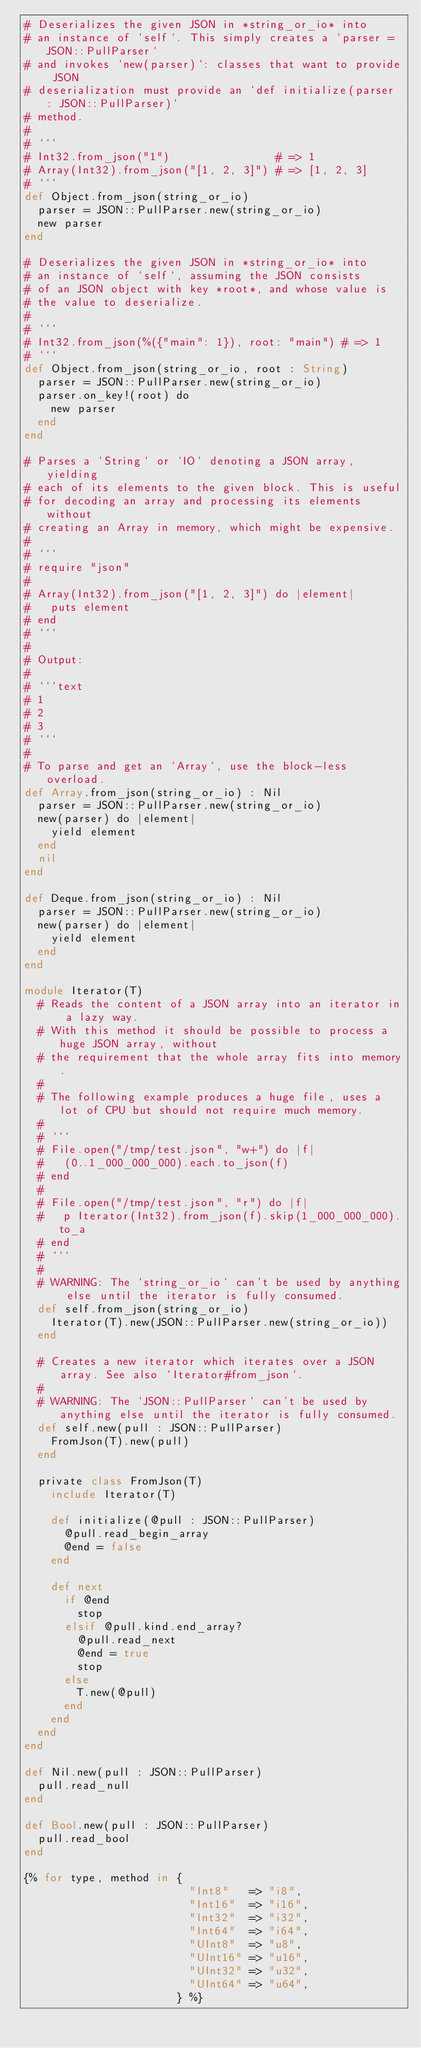<code> <loc_0><loc_0><loc_500><loc_500><_Crystal_># Deserializes the given JSON in *string_or_io* into
# an instance of `self`. This simply creates a `parser = JSON::PullParser`
# and invokes `new(parser)`: classes that want to provide JSON
# deserialization must provide an `def initialize(parser : JSON::PullParser)`
# method.
#
# ```
# Int32.from_json("1")                # => 1
# Array(Int32).from_json("[1, 2, 3]") # => [1, 2, 3]
# ```
def Object.from_json(string_or_io)
  parser = JSON::PullParser.new(string_or_io)
  new parser
end

# Deserializes the given JSON in *string_or_io* into
# an instance of `self`, assuming the JSON consists
# of an JSON object with key *root*, and whose value is
# the value to deserialize.
#
# ```
# Int32.from_json(%({"main": 1}), root: "main") # => 1
# ```
def Object.from_json(string_or_io, root : String)
  parser = JSON::PullParser.new(string_or_io)
  parser.on_key!(root) do
    new parser
  end
end

# Parses a `String` or `IO` denoting a JSON array, yielding
# each of its elements to the given block. This is useful
# for decoding an array and processing its elements without
# creating an Array in memory, which might be expensive.
#
# ```
# require "json"
#
# Array(Int32).from_json("[1, 2, 3]") do |element|
#   puts element
# end
# ```
#
# Output:
#
# ```text
# 1
# 2
# 3
# ```
#
# To parse and get an `Array`, use the block-less overload.
def Array.from_json(string_or_io) : Nil
  parser = JSON::PullParser.new(string_or_io)
  new(parser) do |element|
    yield element
  end
  nil
end

def Deque.from_json(string_or_io) : Nil
  parser = JSON::PullParser.new(string_or_io)
  new(parser) do |element|
    yield element
  end
end

module Iterator(T)
  # Reads the content of a JSON array into an iterator in a lazy way.
  # With this method it should be possible to process a huge JSON array, without
  # the requirement that the whole array fits into memory.
  #
  # The following example produces a huge file, uses a lot of CPU but should not require much memory.
  #
  # ```
  # File.open("/tmp/test.json", "w+") do |f|
  #   (0..1_000_000_000).each.to_json(f)
  # end
  #
  # File.open("/tmp/test.json", "r") do |f|
  #   p Iterator(Int32).from_json(f).skip(1_000_000_000).to_a
  # end
  # ```
  #
  # WARNING: The `string_or_io` can't be used by anything else until the iterator is fully consumed.
  def self.from_json(string_or_io)
    Iterator(T).new(JSON::PullParser.new(string_or_io))
  end

  # Creates a new iterator which iterates over a JSON array. See also `Iterator#from_json`.
  #
  # WARNING: The `JSON::PullParser` can't be used by anything else until the iterator is fully consumed.
  def self.new(pull : JSON::PullParser)
    FromJson(T).new(pull)
  end

  private class FromJson(T)
    include Iterator(T)

    def initialize(@pull : JSON::PullParser)
      @pull.read_begin_array
      @end = false
    end

    def next
      if @end
        stop
      elsif @pull.kind.end_array?
        @pull.read_next
        @end = true
        stop
      else
        T.new(@pull)
      end
    end
  end
end

def Nil.new(pull : JSON::PullParser)
  pull.read_null
end

def Bool.new(pull : JSON::PullParser)
  pull.read_bool
end

{% for type, method in {
                         "Int8"   => "i8",
                         "Int16"  => "i16",
                         "Int32"  => "i32",
                         "Int64"  => "i64",
                         "UInt8"  => "u8",
                         "UInt16" => "u16",
                         "UInt32" => "u32",
                         "UInt64" => "u64",
                       } %}</code> 